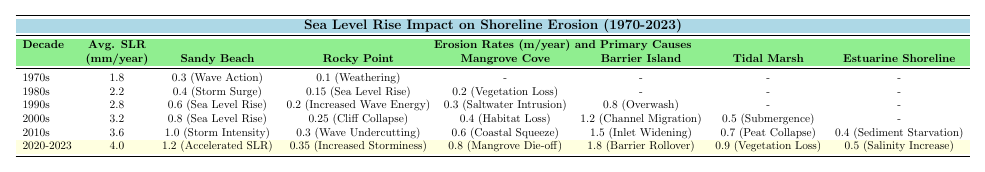What was the average sea level rise during the 1980s? The average sea level rise for the 1980s is provided in the table, which shows it as 2.2 mm/year.
Answer: 2.2 mm/year Which location experienced the highest erosion rate in the 2000s? Looking at the erosion rates for the 2000s, Barrier Island has the highest rate at 1.2 m/year.
Answer: Barrier Island What was the primary cause of erosion at Sandy Beach in the 2010s? In the 2010s, the table indicates that the primary cause of erosion at Sandy Beach was Storm Intensity.
Answer: Storm Intensity How much did the average sea level rise increase from the 1970s to the 2020-2023 period? The average sea level rise in the 1970s was 1.8 mm/year, and in the 2020-2023 period, it was 4.0 mm/year. The increase is 4.0 - 1.8 = 2.2 mm/year.
Answer: 2.2 mm/year Did any location report an erosion rate of zero during the decades covered in the table? By reviewing the erosion rates throughout the decades, it's clear there are no instances of a zero erosion rate recorded for any location across the decades.
Answer: No What was the average erosion rate for Mangrove Cove across all decades provided? To find the average, we add the erosion rates for Mangrove Cove: 0.2 (1980s) + 0.3 (1990s) + 0.4 (2000s) + 0.6 (2010s) + 0.8 (2020-2023) = 2.3 m/year. Then, divide by the number of occurrences (5), resulting in an average of 2.3 / 5 = 0.46 m/year.
Answer: 0.46 m/year Which decade saw the lowest average erosion rate at Rocky Point, and what was that rate? Reviewing the table, the lowest average erosion rate at Rocky Point occurred in the 1970s, with a rate of 0.1 m/year.
Answer: 0.1 m/year How did the primary cause of erosion at Barrier Island change from the 1990s to the 2010s? In the 1990s, the primary cause of erosion at Barrier Island was Overwash, while in the 2010s, it changed to Inlet Widening, indicating a shift in the factors contributing to erosion.
Answer: Changed from Overwash to Inlet Widening Calculate the total erosion rate at Tidal Marsh for all decades listed. The erosion rates for Tidal Marsh are 0.5 (2000s), 0.7 (2010s), and 0.9 (2020-2023). Adding these gives us 0.5 + 0.7 + 0.9 = 2.1 m/year as the total erosion rate across those decades.
Answer: 2.1 m/year In which decade did the erosion rate at Sandy Beach first exceed 0.6 m/year? Referring to the data, Sandy Beach exceeds 0.6 m/year for the first time in the 2000s, where the rate was recorded at 0.8 m/year.
Answer: 2000s What changes occurred in the primary causes of erosion at Mangrove Cove from the 1980s to the 2020-2023 period? At Mangrove Cove, the primary causes of erosion changed from Vegetation Loss (1980s) to Saltwater Intrusion (1990s) and then to Coastal Squeeze (2010s), with the latest cause being Mangrove Die-off (2020-2023). This indicates ongoing ecological changes impacting erosion.
Answer: Vegetation Loss to Mangrove Die-off 